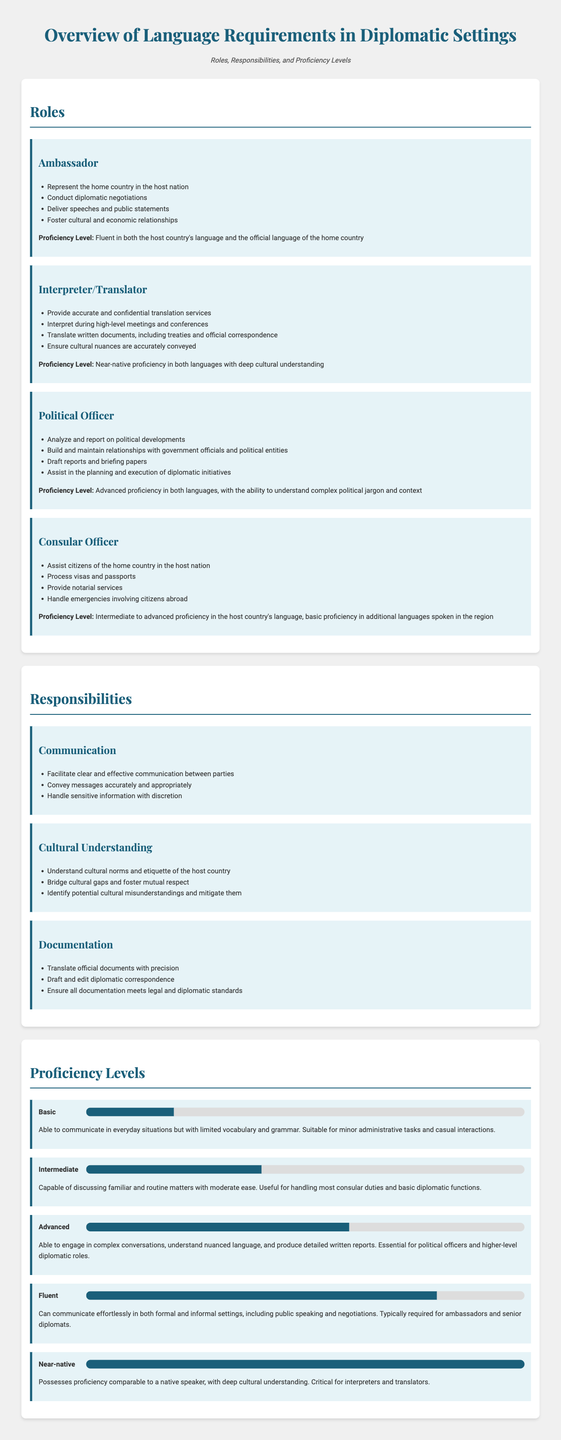What is the primary role of an ambassador? The primary role of an ambassador is to represent the home country in the host nation.
Answer: Represent the home country in the host nation What proficiency level is required for an interpreter/translator? An interpreter/translator is required to have near-native proficiency in both languages with deep cultural understanding.
Answer: Near-native proficiency What is one responsibility related to cultural understanding? One responsibility related to cultural understanding is to bridge cultural gaps and foster mutual respect.
Answer: Bridge cultural gaps and foster mutual respect What is the proficiency level that allows communication in everyday situations? The proficiency level that allows communication in everyday situations is Basic.
Answer: Basic How many roles are listed in the document? There are four roles listed in the document.
Answer: Four roles What is the necessary proficiency level for political officers? Political officers need an advanced proficiency in both languages.
Answer: Advanced proficiency What task is a consular officer responsible for? A consular officer is responsible for processing visas and passports.
Answer: Process visas and passports What is the maximum proficiency level mentioned in the document? The maximum proficiency level mentioned in the document is Near-native.
Answer: Near-native What does the advanced proficiency level enable a diplomat to do? The advanced proficiency level enables a diplomat to engage in complex conversations.
Answer: Engage in complex conversations 